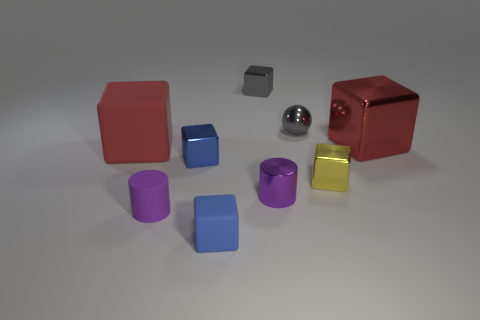Do the small matte block and the rubber thing that is behind the yellow cube have the same color?
Offer a terse response. No. The big red thing that is the same material as the tiny gray cube is what shape?
Offer a terse response. Cube. How many red metal cubes are there?
Your response must be concise. 1. What number of objects are either purple cylinders that are on the left side of the tiny blue rubber object or green cylinders?
Make the answer very short. 1. Does the small cylinder that is on the left side of the blue rubber cube have the same color as the shiny cylinder?
Provide a succinct answer. Yes. How many other things are there of the same color as the big shiny cube?
Your answer should be compact. 1. How many big things are cyan shiny cylinders or metal spheres?
Offer a terse response. 0. Are there more metal objects than red rubber things?
Keep it short and to the point. Yes. Do the tiny yellow cube and the small gray ball have the same material?
Your response must be concise. Yes. Is there any other thing that has the same material as the tiny gray block?
Offer a very short reply. Yes. 